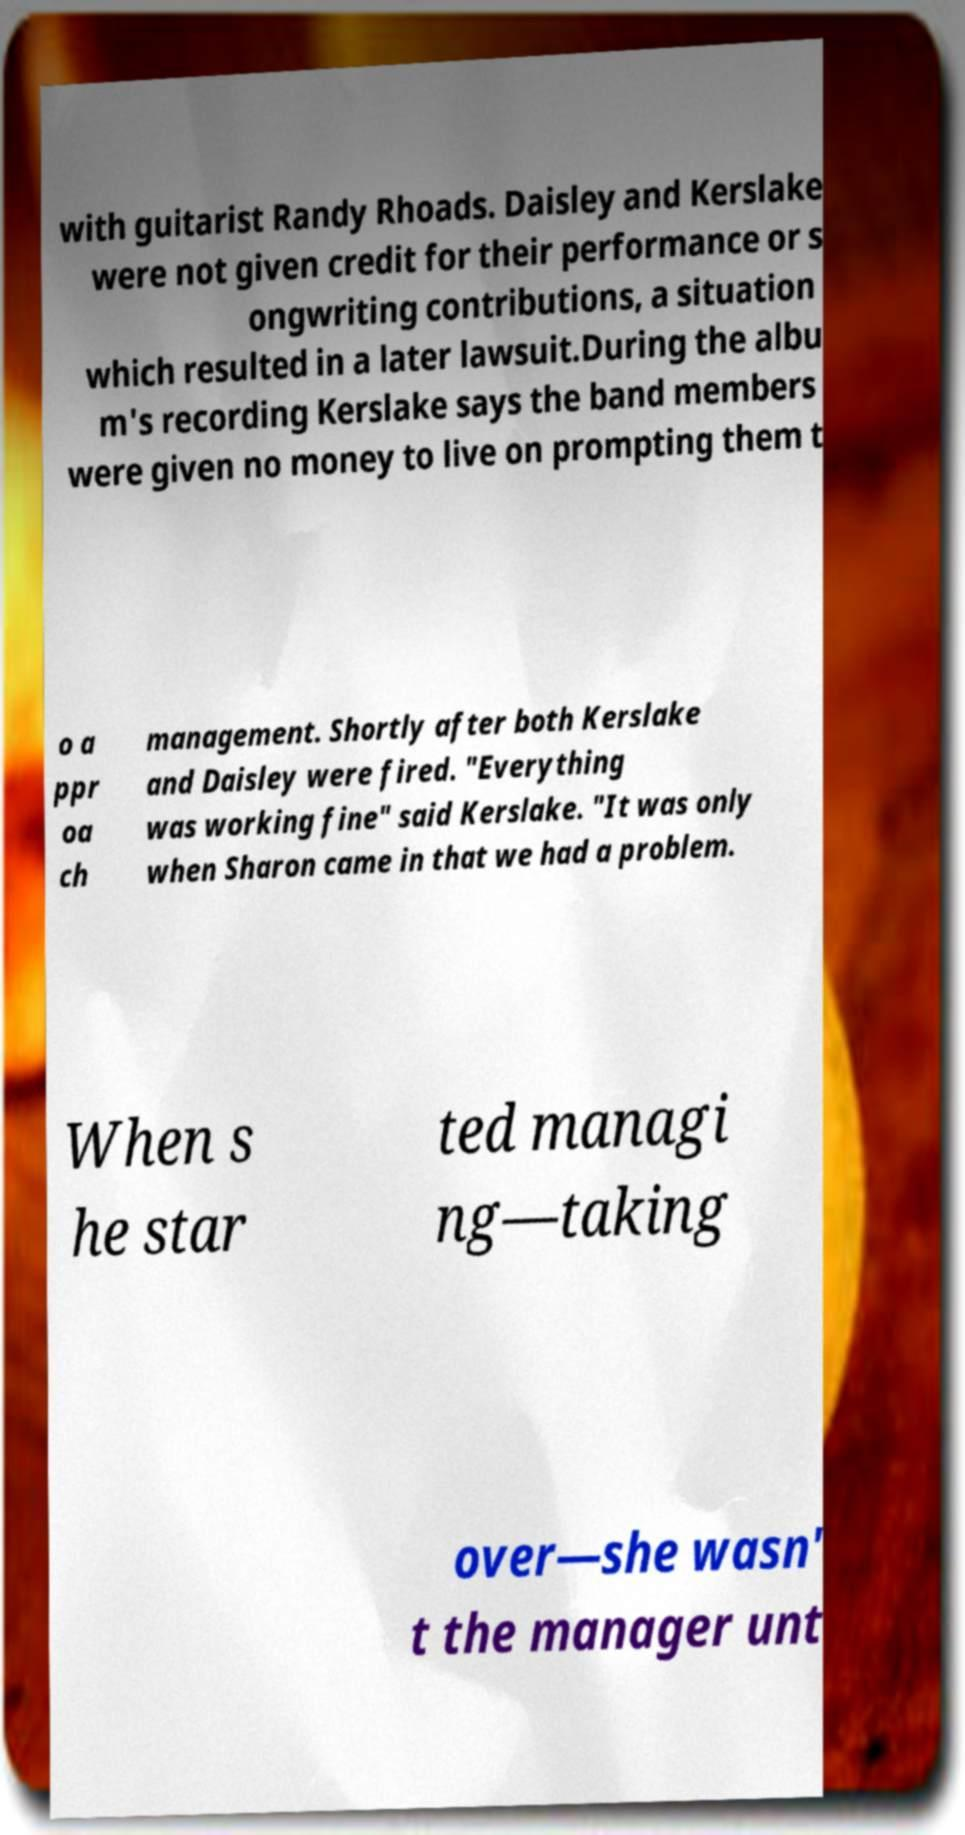Please read and relay the text visible in this image. What does it say? with guitarist Randy Rhoads. Daisley and Kerslake were not given credit for their performance or s ongwriting contributions, a situation which resulted in a later lawsuit.During the albu m's recording Kerslake says the band members were given no money to live on prompting them t o a ppr oa ch management. Shortly after both Kerslake and Daisley were fired. "Everything was working fine" said Kerslake. "It was only when Sharon came in that we had a problem. When s he star ted managi ng—taking over—she wasn' t the manager unt 